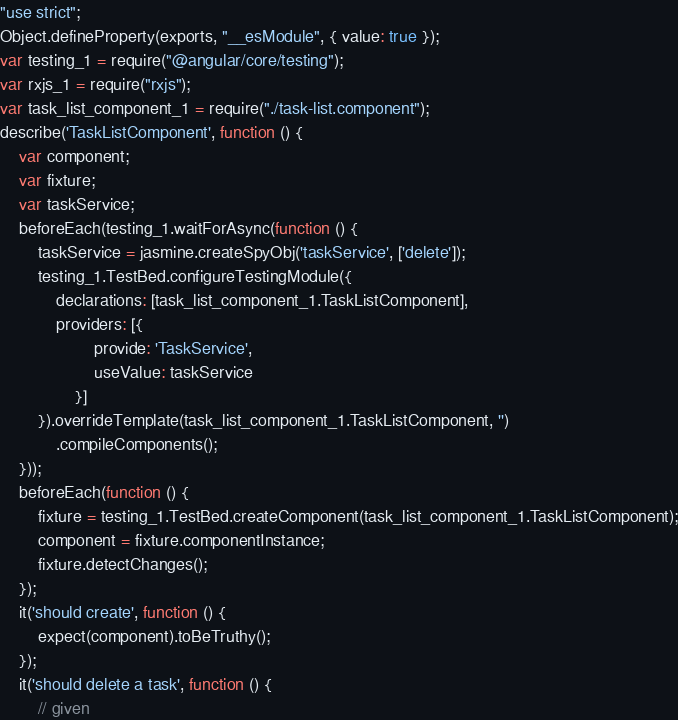<code> <loc_0><loc_0><loc_500><loc_500><_JavaScript_>"use strict";
Object.defineProperty(exports, "__esModule", { value: true });
var testing_1 = require("@angular/core/testing");
var rxjs_1 = require("rxjs");
var task_list_component_1 = require("./task-list.component");
describe('TaskListComponent', function () {
    var component;
    var fixture;
    var taskService;
    beforeEach(testing_1.waitForAsync(function () {
        taskService = jasmine.createSpyObj('taskService', ['delete']);
        testing_1.TestBed.configureTestingModule({
            declarations: [task_list_component_1.TaskListComponent],
            providers: [{
                    provide: 'TaskService',
                    useValue: taskService
                }]
        }).overrideTemplate(task_list_component_1.TaskListComponent, '')
            .compileComponents();
    }));
    beforeEach(function () {
        fixture = testing_1.TestBed.createComponent(task_list_component_1.TaskListComponent);
        component = fixture.componentInstance;
        fixture.detectChanges();
    });
    it('should create', function () {
        expect(component).toBeTruthy();
    });
    it('should delete a task', function () {
        // given</code> 